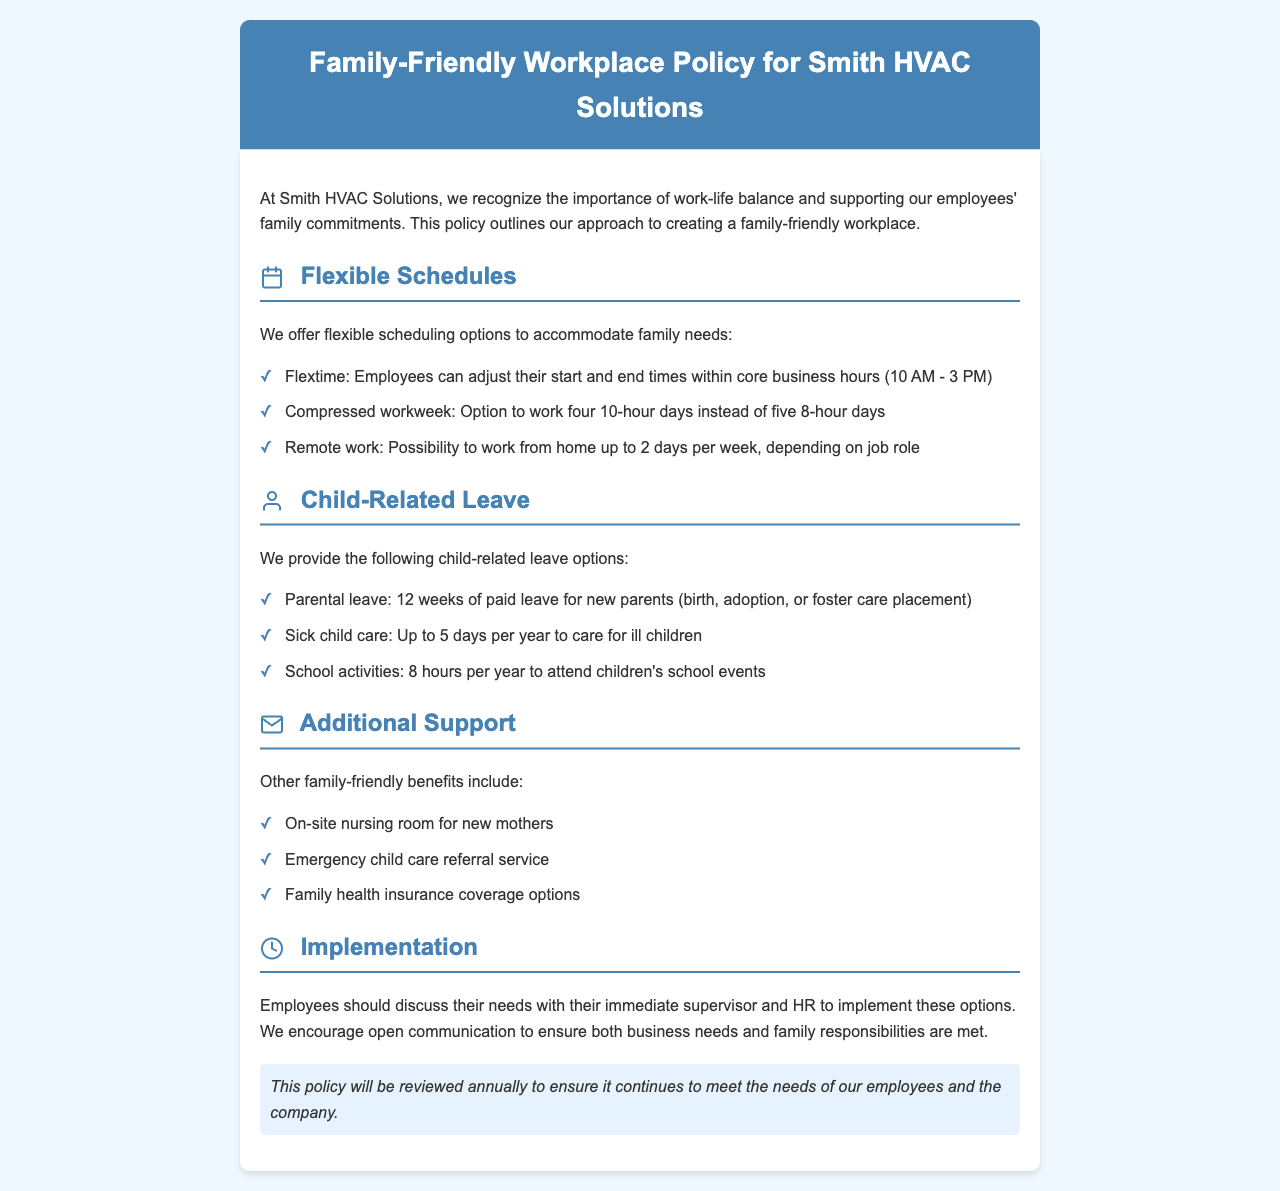What are the core business hours for flexible scheduling? The core business hours for flexible scheduling are from 10 AM to 3 PM, as mentioned under flexible schedules.
Answer: 10 AM - 3 PM How many weeks of paid parental leave do new parents receive? The document states that new parents receive 12 weeks of paid parental leave for birth, adoption, or foster care placement.
Answer: 12 weeks How many hours per year can employees take to attend children's school events? The policy provides 8 hours per year for employees to attend children's school events.
Answer: 8 hours What option is available for working fewer days in a week? The compressed workweek option allows employees to work four 10-hour days instead of five 8-hour days.
Answer: Four 10-hour days What is one additional support benefit mentioned in the policy? The policy outlines the availability of an on-site nursing room for new mothers as an additional support benefit.
Answer: On-site nursing room What should employees do to implement flexible scheduling options? Employees should discuss their needs with their immediate supervisor and HR to implement these options.
Answer: Discuss with supervisor and HR How often will this policy be reviewed? The document states that this policy will be reviewed annually to ensure it meets the needs of employees and the company.
Answer: Annually What is the maximum number of sick child care days provided per year? The policy allows up to 5 days per year to care for ill children.
Answer: 5 days 